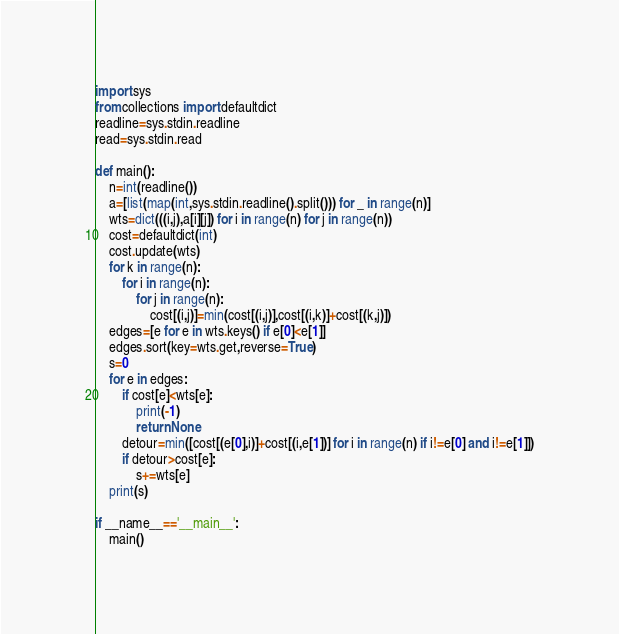<code> <loc_0><loc_0><loc_500><loc_500><_Python_>import sys
from collections import defaultdict
readline=sys.stdin.readline
read=sys.stdin.read

def main():
    n=int(readline())
    a=[list(map(int,sys.stdin.readline().split())) for _ in range(n)]
    wts=dict(((i,j),a[i][j]) for i in range(n) for j in range(n))
    cost=defaultdict(int)
    cost.update(wts)
    for k in range(n):
        for i in range(n):
            for j in range(n):
                cost[(i,j)]=min(cost[(i,j)],cost[(i,k)]+cost[(k,j)])
    edges=[e for e in wts.keys() if e[0]<e[1]]
    edges.sort(key=wts.get,reverse=True)
    s=0
    for e in edges:
        if cost[e]<wts[e]:
            print(-1)
            return None
        detour=min([cost[(e[0],i)]+cost[(i,e[1])] for i in range(n) if i!=e[0] and i!=e[1]])
        if detour>cost[e]:
            s+=wts[e]
    print(s)

if __name__=='__main__':
    main()
</code> 